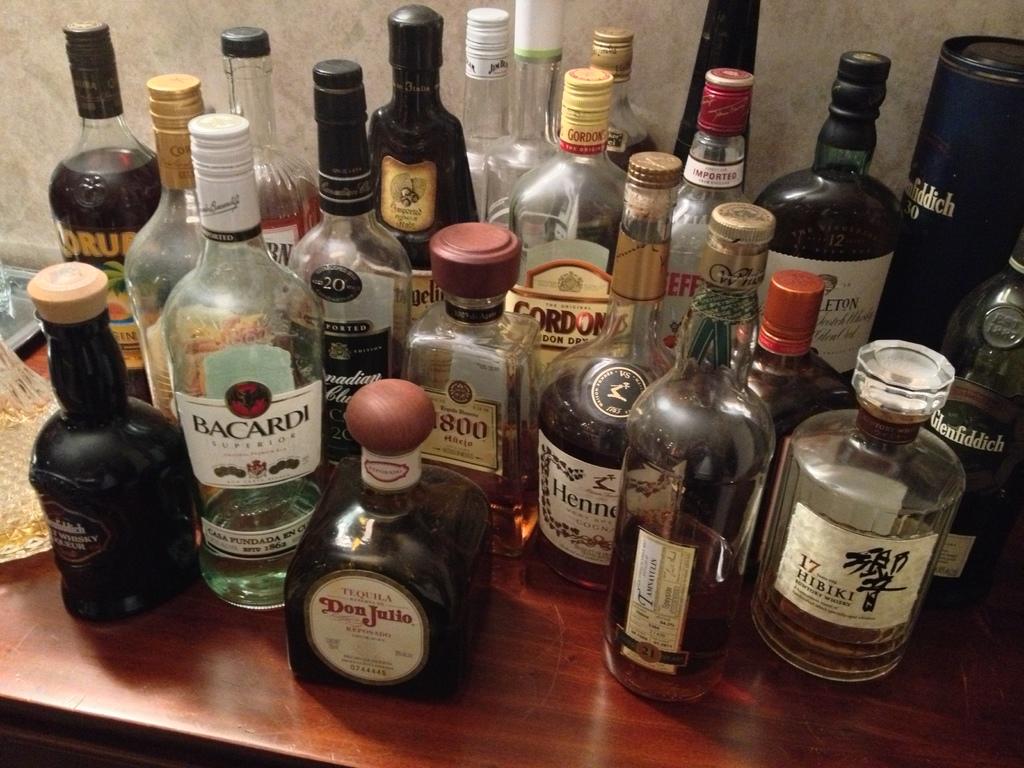What brand of liquor is in the clear bottle in front with the white label?
Your answer should be compact. Bacardi. 